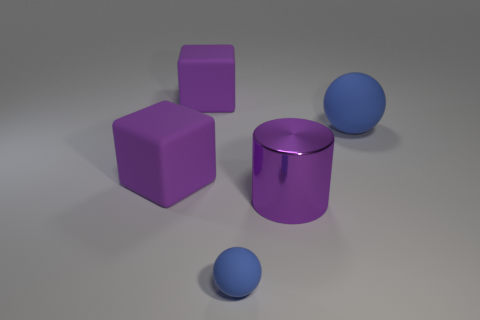There is a blue thing behind the blue matte ball that is left of the big purple shiny object; what shape is it?
Give a very brief answer. Sphere. Is the number of green objects less than the number of purple metal cylinders?
Your answer should be compact. Yes. What is the color of the big matte thing that is on the right side of the purple cylinder?
Make the answer very short. Blue. There is a big object that is both right of the tiny blue sphere and in front of the large matte sphere; what material is it?
Keep it short and to the point. Metal. What shape is the other blue thing that is made of the same material as the large blue thing?
Offer a terse response. Sphere. What number of large purple rubber blocks are in front of the blue ball that is to the right of the tiny rubber thing?
Provide a succinct answer. 1. What number of blue objects are both in front of the metal thing and on the right side of the tiny blue thing?
Offer a very short reply. 0. What number of other objects are there of the same material as the cylinder?
Provide a succinct answer. 0. What color is the large rubber block in front of the blue rubber sphere that is right of the large purple cylinder?
Give a very brief answer. Purple. Is the color of the big thing behind the big sphere the same as the shiny cylinder?
Your response must be concise. Yes. 